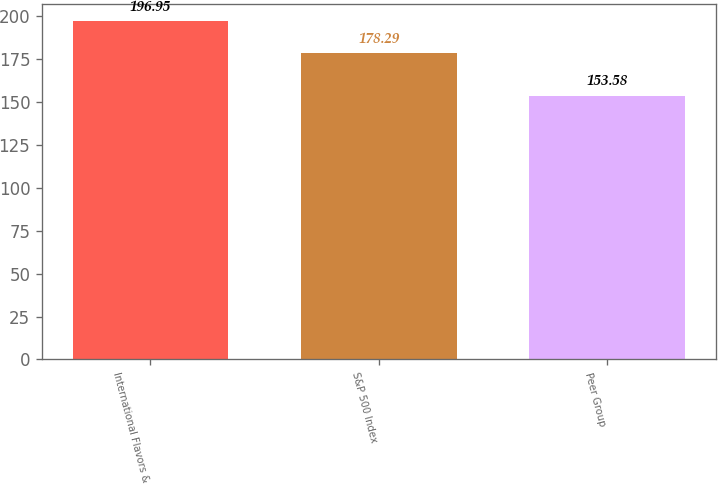<chart> <loc_0><loc_0><loc_500><loc_500><bar_chart><fcel>International Flavors &<fcel>S&P 500 Index<fcel>Peer Group<nl><fcel>196.95<fcel>178.29<fcel>153.58<nl></chart> 